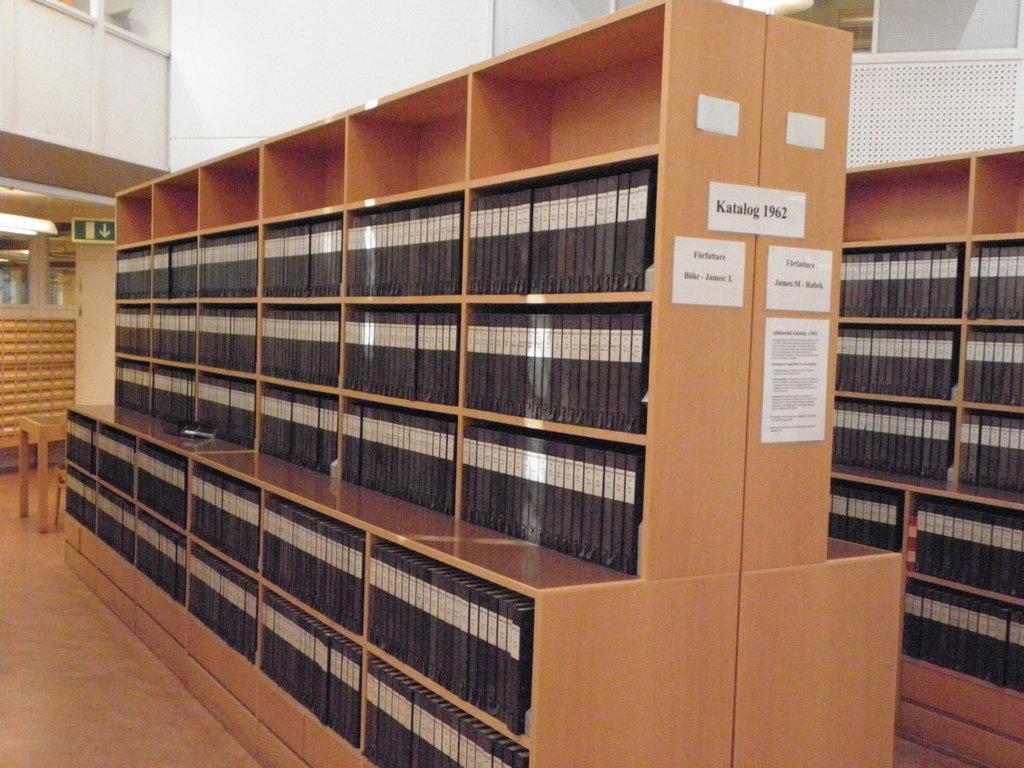What is the date written at the top?
Your answer should be compact. 1962. What is written before the numbers?
Keep it short and to the point. Katalog. 